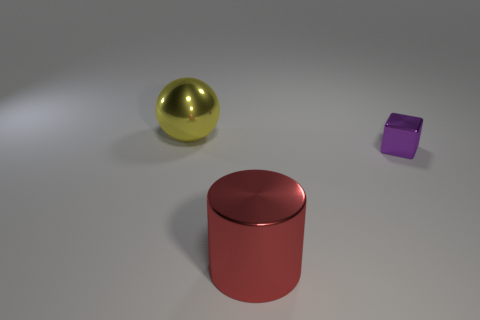Add 3 red cylinders. How many objects exist? 6 Subtract all balls. How many objects are left? 2 Add 1 metal blocks. How many metal blocks exist? 2 Subtract 0 green cylinders. How many objects are left? 3 Subtract all cylinders. Subtract all red cylinders. How many objects are left? 1 Add 3 metallic balls. How many metallic balls are left? 4 